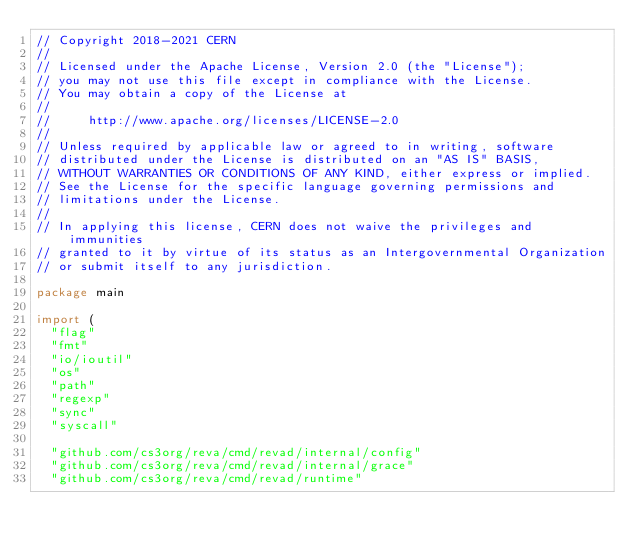Convert code to text. <code><loc_0><loc_0><loc_500><loc_500><_Go_>// Copyright 2018-2021 CERN
//
// Licensed under the Apache License, Version 2.0 (the "License");
// you may not use this file except in compliance with the License.
// You may obtain a copy of the License at
//
//     http://www.apache.org/licenses/LICENSE-2.0
//
// Unless required by applicable law or agreed to in writing, software
// distributed under the License is distributed on an "AS IS" BASIS,
// WITHOUT WARRANTIES OR CONDITIONS OF ANY KIND, either express or implied.
// See the License for the specific language governing permissions and
// limitations under the License.
//
// In applying this license, CERN does not waive the privileges and immunities
// granted to it by virtue of its status as an Intergovernmental Organization
// or submit itself to any jurisdiction.

package main

import (
	"flag"
	"fmt"
	"io/ioutil"
	"os"
	"path"
	"regexp"
	"sync"
	"syscall"

	"github.com/cs3org/reva/cmd/revad/internal/config"
	"github.com/cs3org/reva/cmd/revad/internal/grace"
	"github.com/cs3org/reva/cmd/revad/runtime"</code> 